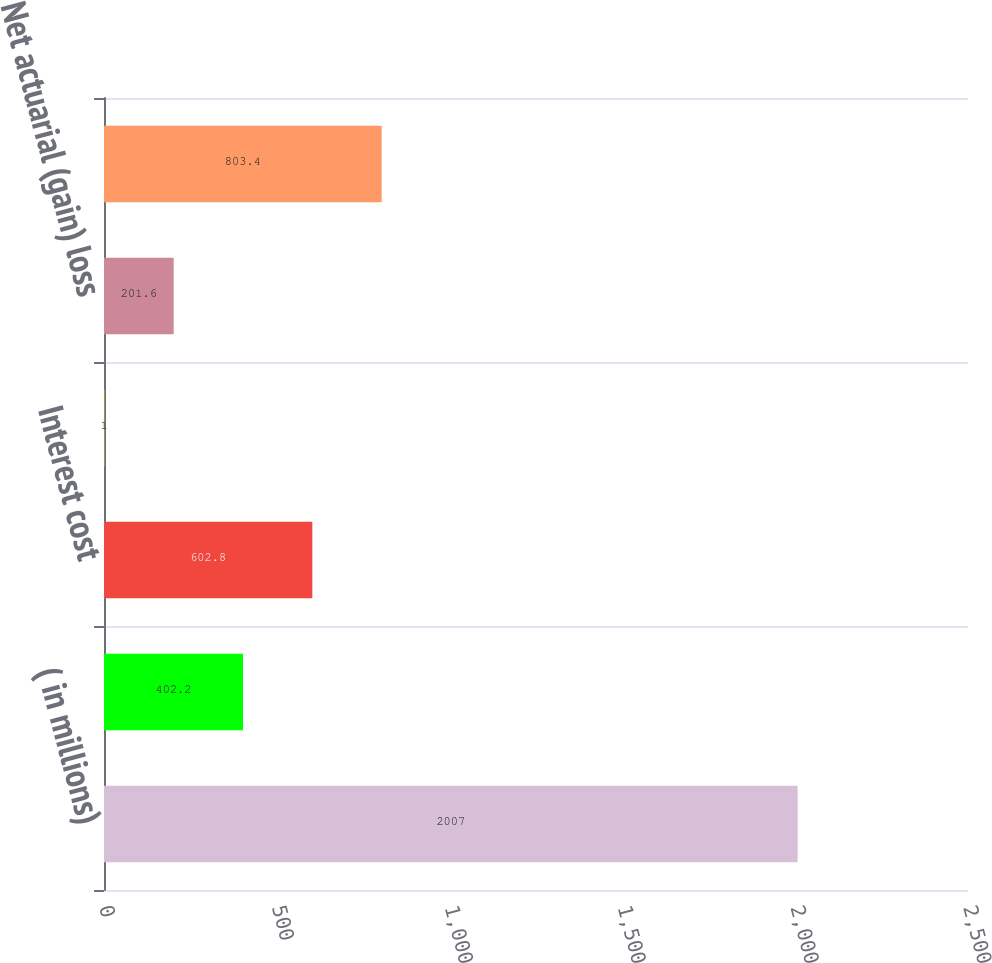<chart> <loc_0><loc_0><loc_500><loc_500><bar_chart><fcel>( in millions)<fcel>Service cost<fcel>Interest cost<fcel>Prior service (credit) cost<fcel>Net actuarial (gain) loss<fcel>Net periodic cost<nl><fcel>2007<fcel>402.2<fcel>602.8<fcel>1<fcel>201.6<fcel>803.4<nl></chart> 